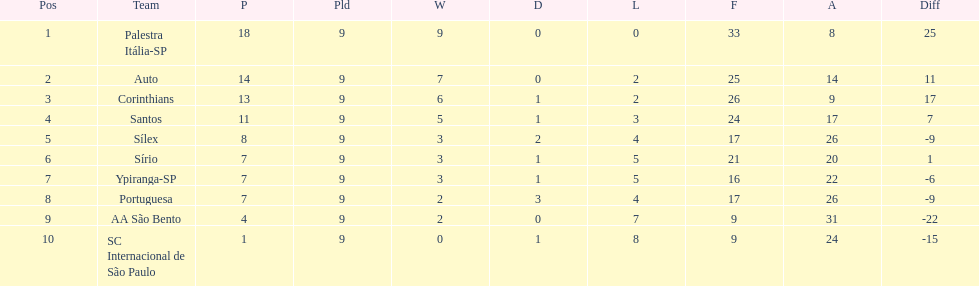In 1926 brazilian football,aside from the first place team, what other teams had winning records? Auto, Corinthians, Santos. 